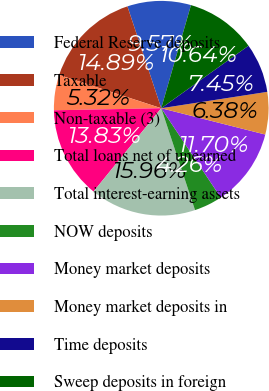<chart> <loc_0><loc_0><loc_500><loc_500><pie_chart><fcel>Federal Reserve deposits<fcel>Taxable<fcel>Non-taxable (3)<fcel>Total loans net of unearned<fcel>Total interest-earning assets<fcel>NOW deposits<fcel>Money market deposits<fcel>Money market deposits in<fcel>Time deposits<fcel>Sweep deposits in foreign<nl><fcel>9.57%<fcel>14.89%<fcel>5.32%<fcel>13.83%<fcel>15.96%<fcel>4.26%<fcel>11.7%<fcel>6.38%<fcel>7.45%<fcel>10.64%<nl></chart> 